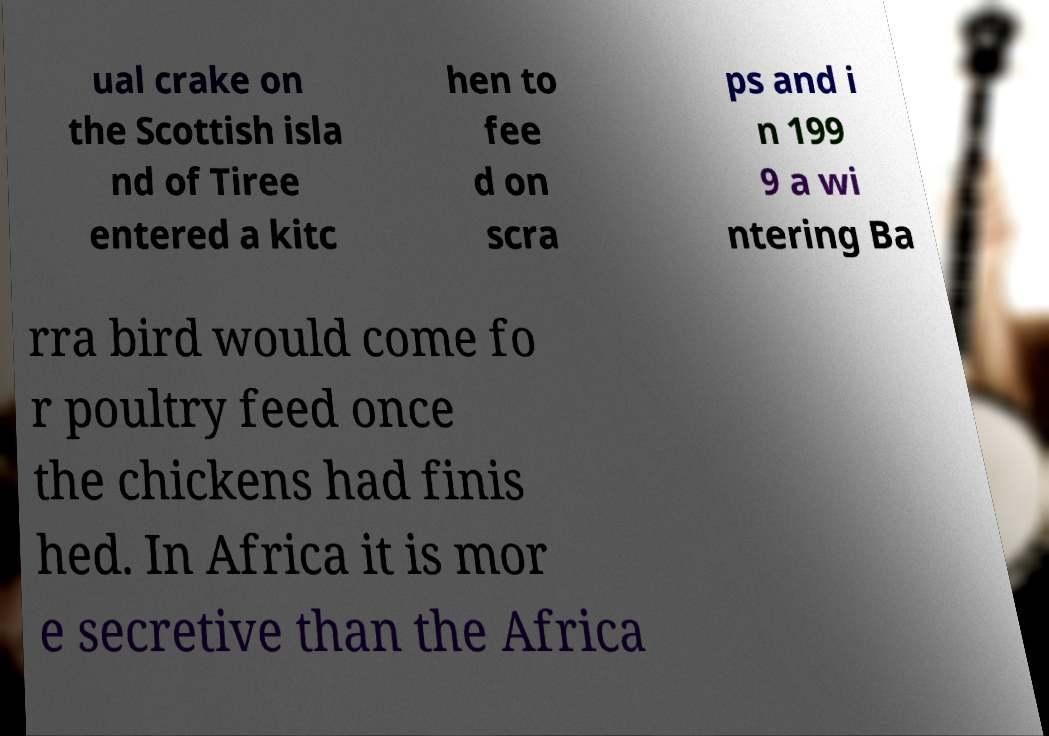Please identify and transcribe the text found in this image. ual crake on the Scottish isla nd of Tiree entered a kitc hen to fee d on scra ps and i n 199 9 a wi ntering Ba rra bird would come fo r poultry feed once the chickens had finis hed. In Africa it is mor e secretive than the Africa 